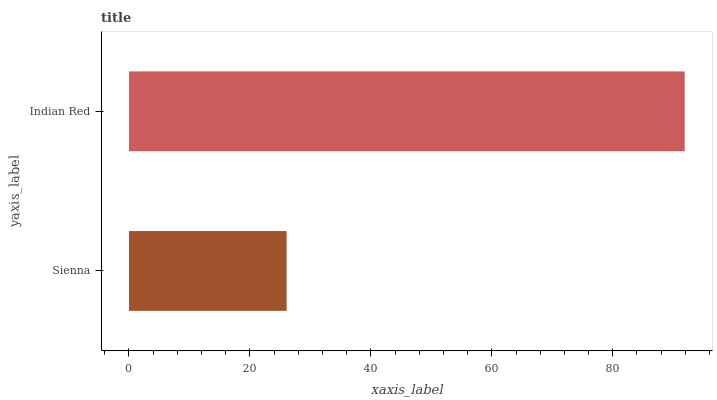Is Sienna the minimum?
Answer yes or no. Yes. Is Indian Red the maximum?
Answer yes or no. Yes. Is Indian Red the minimum?
Answer yes or no. No. Is Indian Red greater than Sienna?
Answer yes or no. Yes. Is Sienna less than Indian Red?
Answer yes or no. Yes. Is Sienna greater than Indian Red?
Answer yes or no. No. Is Indian Red less than Sienna?
Answer yes or no. No. Is Indian Red the high median?
Answer yes or no. Yes. Is Sienna the low median?
Answer yes or no. Yes. Is Sienna the high median?
Answer yes or no. No. Is Indian Red the low median?
Answer yes or no. No. 